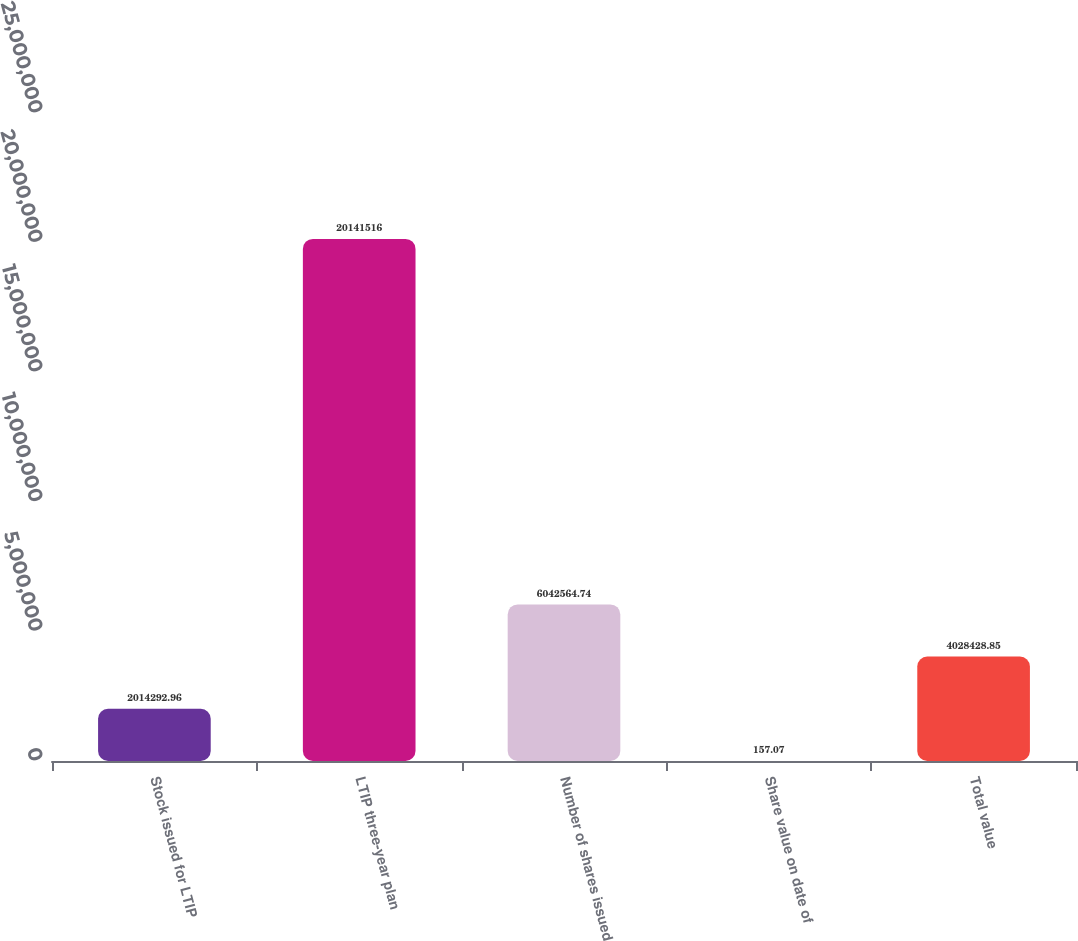<chart> <loc_0><loc_0><loc_500><loc_500><bar_chart><fcel>Stock issued for LTIP<fcel>LTIP three-year plan<fcel>Number of shares issued<fcel>Share value on date of<fcel>Total value<nl><fcel>2.01429e+06<fcel>2.01415e+07<fcel>6.04256e+06<fcel>157.07<fcel>4.02843e+06<nl></chart> 